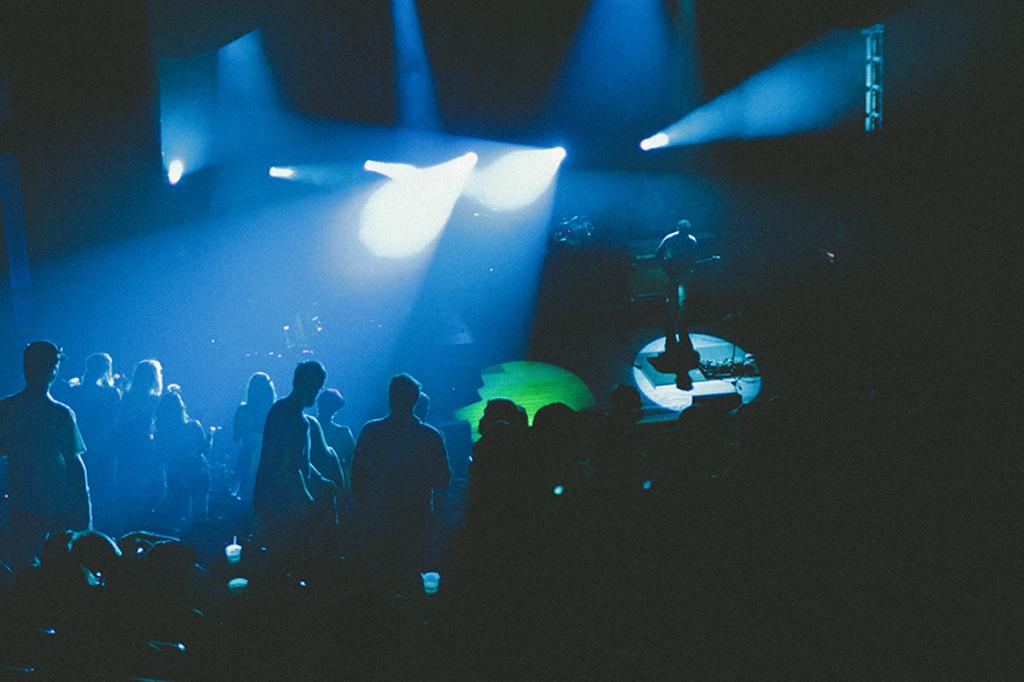How many people are in the image? There are many people in the image. What are the people in the image doing? The people are standing together. What can be seen on the stage in the image? A person is playing a guitar on the stage. Can you see any pipes emitting smoke in the image? There are no pipes or smoke present in the image. Is there a baseball game happening in the image? There is no baseball game or any reference to baseball in the image. 